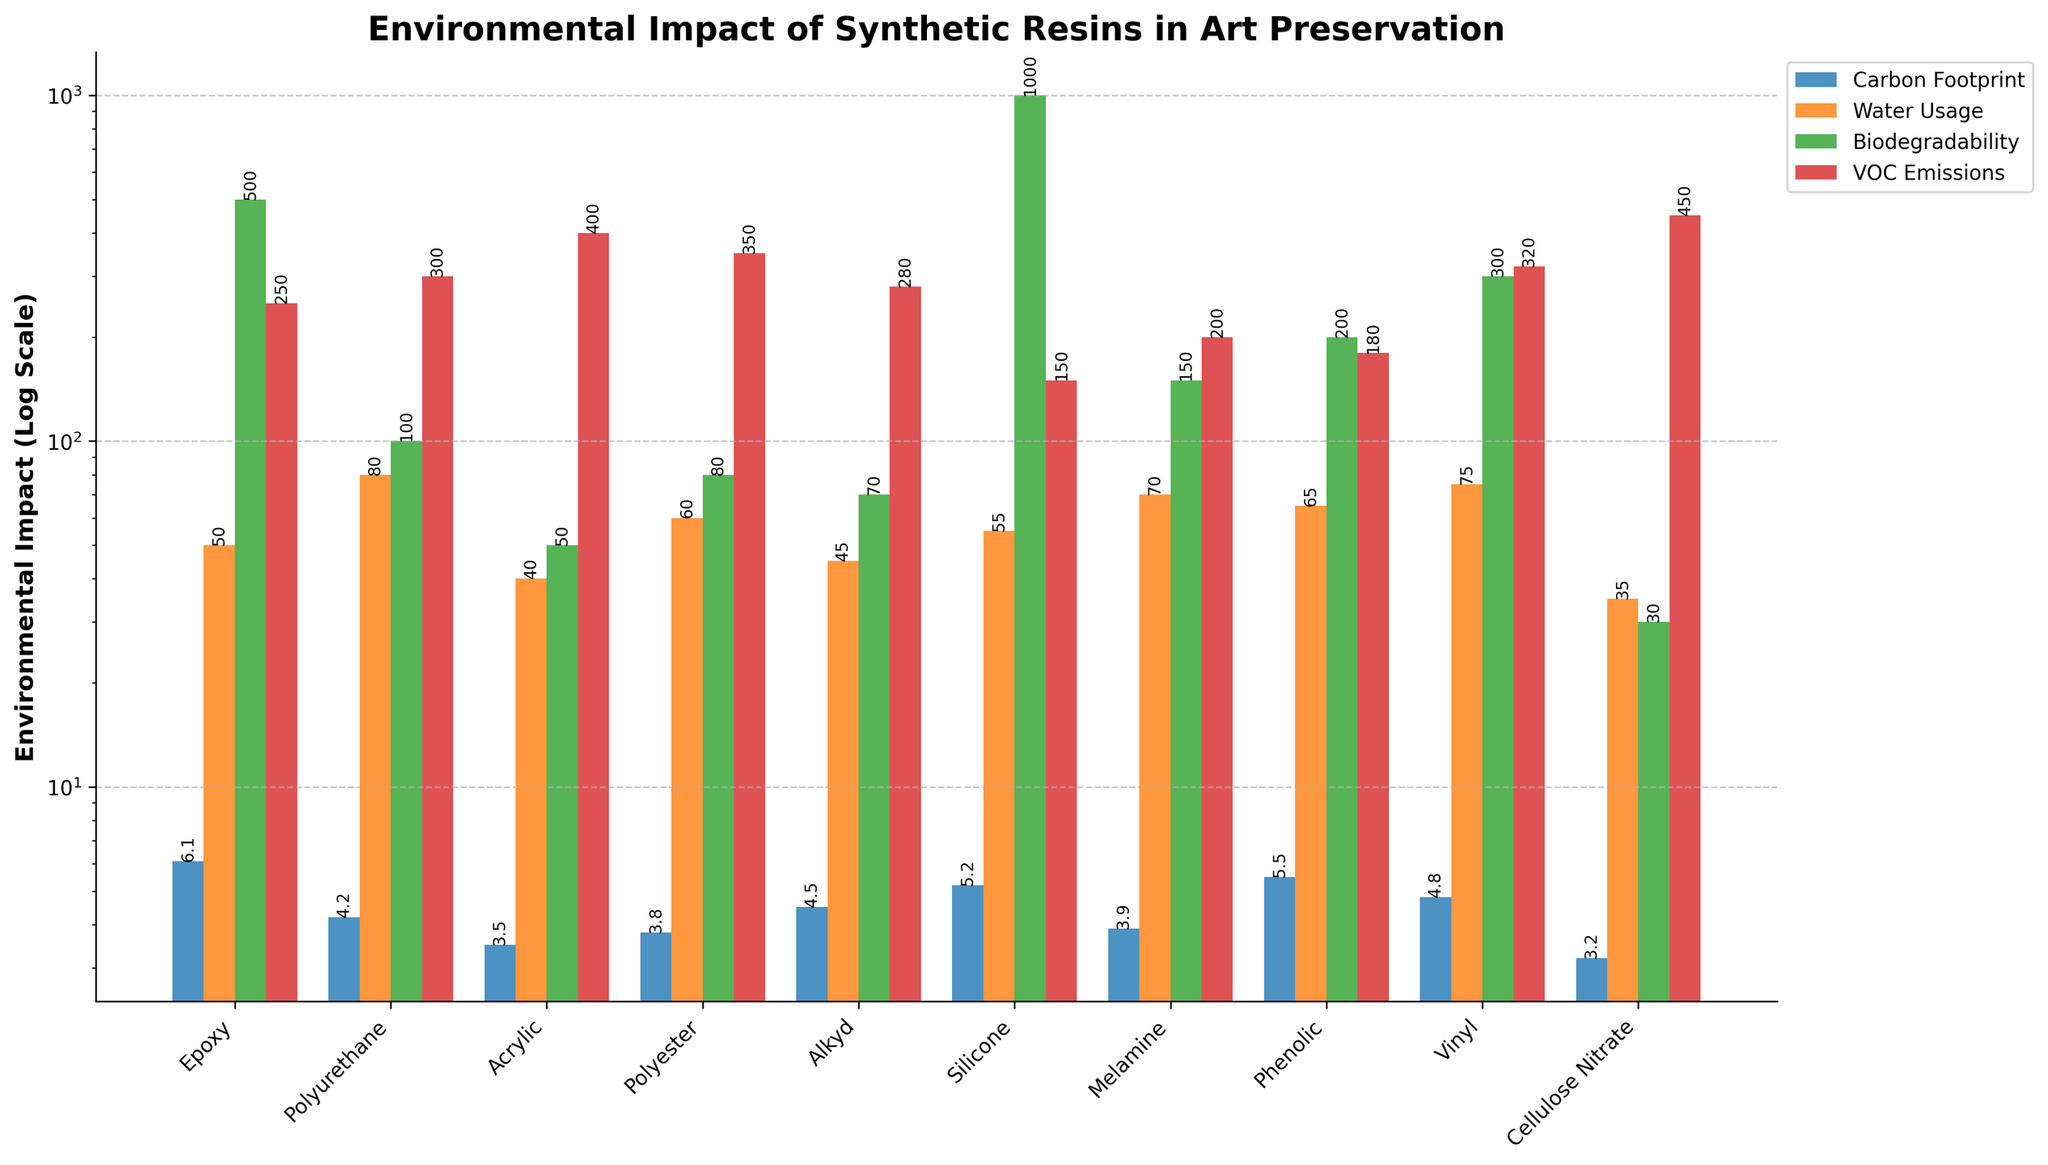Which resin type has the highest VOC emissions? The bar that represents VOC emissions has the highest value for Acrylic resin. This is visually represented by the tallest red bar in the VOC emissions category.
Answer: Acrylic Which resin has the lowest water usage? The bar for water usage is lowest for Cellulose Nitrate, as indicated by the smallest orange bar in the water usage category.
Answer: Cellulose Nitrate Compare the biodegradability of Epoxy and Melamine resins. Which one is better for the environment based on this metric? Biodegradability is lower for Melamine (150 years) compared to Epoxy (500 years). Therefore, Melamine is better for the environment based on biodegradability.
Answer: Melamine What is the sum of the carbon footprint and water usage for Silicone resin? For Silicone resin, the carbon footprint is 5.2 kg CO2e/kg and water usage is 55 L/kg. Summing these: 5.2 + 55 = 60.2.
Answer: 60.2 Which resin type has the shortest biodegradability period? The shortest biodegradability period is shown by the smallest green bar in that category, corresponding to Cellulose Nitrate at 30 years.
Answer: Cellulose Nitrate What is the range of carbon footprint values across all resins, and which resins correspond to the minimum and maximum values? The carbon footprint ranges from the smallest value for Cellulose Nitrate (3.2 kg CO2e/kg) to the highest value for Epoxy (6.1 kg CO2e/kg).
Answer: 3.2 - 6.1, Cellulose Nitrate, Epoxy How do the VOC emissions for Polyurethane and Vinyl resins compare? Polyurethane has VOC emissions of 300 g/L, and Vinyl has 320 g/L, making Vinyl slightly higher in VOC emissions.
Answer: Vinyl Which resin type shows the highest water usage and what is its value? The highest water usage is indicated by the tallest orange bar which corresponds to Polyurethane, with a value of 80 L/kg.
Answer: Polyurethane Identify the resin with the highest carbon footprint and compare its biodegradability with that of the resin with the lowest water usage. The resin with the highest carbon footprint is Epoxy (6.1 kg CO2e/kg). Comparing its biodegradability (500 years) with that of the resin with the lowest water usage (Cellulose Nitrate, 30 years), Epoxy has a significantly higher biodegradability period.
Answer: Epoxy, 500 vs. 30 What are the differences in carbon footprint and VOC emissions between Alkyd and Melamine resins? The carbon footprint of Alkyd is 4.5 kg CO2e/kg, and for Melamine, it is 3.9 kg CO2e/kg. The difference is 4.5 - 3.9 = 0.6 kg CO2e/kg. The VOC emissions for Alkyd are 280 g/L and for Melamine are 200 g/L, giving a difference of 280 - 200 = 80 g/L.
Answer: 0.6 kg CO2e/kg, 80 g/L 